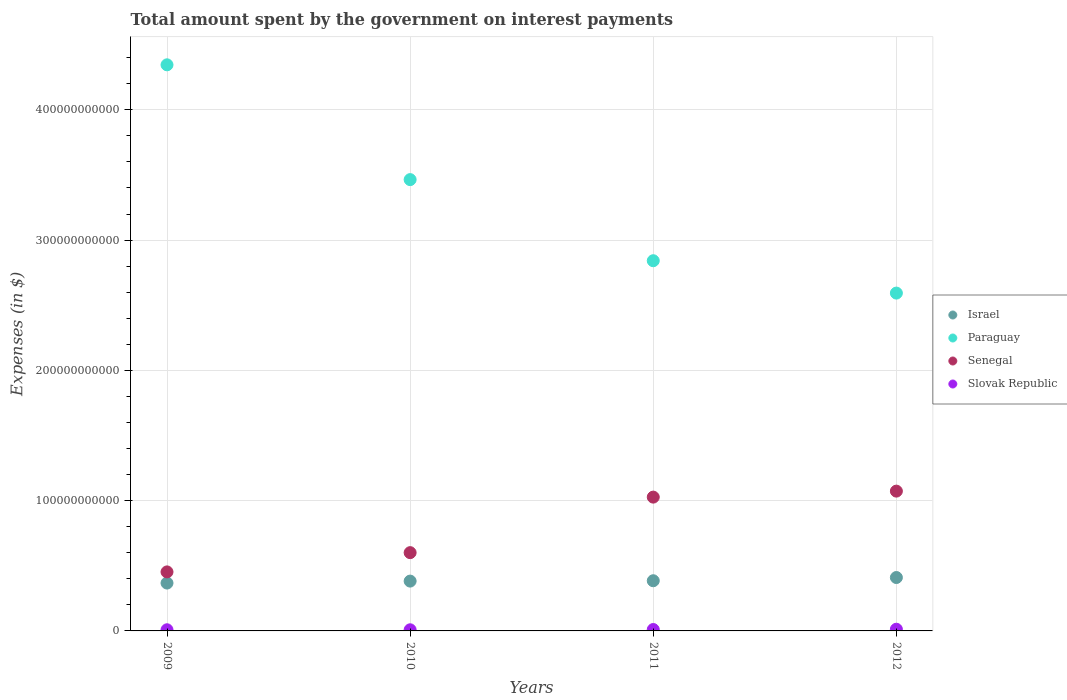How many different coloured dotlines are there?
Your answer should be compact. 4. What is the amount spent on interest payments by the government in Paraguay in 2012?
Make the answer very short. 2.59e+11. Across all years, what is the maximum amount spent on interest payments by the government in Senegal?
Your response must be concise. 1.07e+11. Across all years, what is the minimum amount spent on interest payments by the government in Slovak Republic?
Offer a very short reply. 8.71e+08. In which year was the amount spent on interest payments by the government in Paraguay maximum?
Provide a succinct answer. 2009. What is the total amount spent on interest payments by the government in Paraguay in the graph?
Provide a succinct answer. 1.32e+12. What is the difference between the amount spent on interest payments by the government in Paraguay in 2009 and that in 2011?
Provide a short and direct response. 1.50e+11. What is the difference between the amount spent on interest payments by the government in Israel in 2012 and the amount spent on interest payments by the government in Slovak Republic in 2009?
Offer a terse response. 4.01e+1. What is the average amount spent on interest payments by the government in Paraguay per year?
Make the answer very short. 3.31e+11. In the year 2012, what is the difference between the amount spent on interest payments by the government in Israel and amount spent on interest payments by the government in Senegal?
Your answer should be very brief. -6.63e+1. In how many years, is the amount spent on interest payments by the government in Israel greater than 240000000000 $?
Give a very brief answer. 0. What is the ratio of the amount spent on interest payments by the government in Slovak Republic in 2011 to that in 2012?
Your response must be concise. 0.83. Is the amount spent on interest payments by the government in Paraguay in 2010 less than that in 2012?
Provide a short and direct response. No. What is the difference between the highest and the second highest amount spent on interest payments by the government in Israel?
Make the answer very short. 2.47e+09. What is the difference between the highest and the lowest amount spent on interest payments by the government in Senegal?
Provide a succinct answer. 6.20e+1. In how many years, is the amount spent on interest payments by the government in Slovak Republic greater than the average amount spent on interest payments by the government in Slovak Republic taken over all years?
Give a very brief answer. 2. Is the sum of the amount spent on interest payments by the government in Paraguay in 2009 and 2012 greater than the maximum amount spent on interest payments by the government in Senegal across all years?
Your response must be concise. Yes. Is the amount spent on interest payments by the government in Senegal strictly greater than the amount spent on interest payments by the government in Slovak Republic over the years?
Offer a terse response. Yes. Is the amount spent on interest payments by the government in Israel strictly less than the amount spent on interest payments by the government in Senegal over the years?
Provide a succinct answer. Yes. How many dotlines are there?
Offer a terse response. 4. What is the difference between two consecutive major ticks on the Y-axis?
Offer a terse response. 1.00e+11. How many legend labels are there?
Keep it short and to the point. 4. What is the title of the graph?
Your response must be concise. Total amount spent by the government on interest payments. What is the label or title of the Y-axis?
Provide a succinct answer. Expenses (in $). What is the Expenses (in $) in Israel in 2009?
Offer a very short reply. 3.67e+1. What is the Expenses (in $) of Paraguay in 2009?
Provide a succinct answer. 4.35e+11. What is the Expenses (in $) of Senegal in 2009?
Offer a very short reply. 4.53e+1. What is the Expenses (in $) in Slovak Republic in 2009?
Ensure brevity in your answer.  8.80e+08. What is the Expenses (in $) in Israel in 2010?
Provide a short and direct response. 3.82e+1. What is the Expenses (in $) of Paraguay in 2010?
Keep it short and to the point. 3.46e+11. What is the Expenses (in $) of Senegal in 2010?
Your response must be concise. 6.01e+1. What is the Expenses (in $) of Slovak Republic in 2010?
Offer a terse response. 8.71e+08. What is the Expenses (in $) of Israel in 2011?
Make the answer very short. 3.85e+1. What is the Expenses (in $) in Paraguay in 2011?
Provide a short and direct response. 2.84e+11. What is the Expenses (in $) of Senegal in 2011?
Your response must be concise. 1.03e+11. What is the Expenses (in $) in Slovak Republic in 2011?
Make the answer very short. 1.07e+09. What is the Expenses (in $) of Israel in 2012?
Your response must be concise. 4.10e+1. What is the Expenses (in $) of Paraguay in 2012?
Ensure brevity in your answer.  2.59e+11. What is the Expenses (in $) of Senegal in 2012?
Provide a succinct answer. 1.07e+11. What is the Expenses (in $) of Slovak Republic in 2012?
Offer a very short reply. 1.30e+09. Across all years, what is the maximum Expenses (in $) of Israel?
Your answer should be compact. 4.10e+1. Across all years, what is the maximum Expenses (in $) in Paraguay?
Ensure brevity in your answer.  4.35e+11. Across all years, what is the maximum Expenses (in $) of Senegal?
Provide a short and direct response. 1.07e+11. Across all years, what is the maximum Expenses (in $) of Slovak Republic?
Make the answer very short. 1.30e+09. Across all years, what is the minimum Expenses (in $) in Israel?
Give a very brief answer. 3.67e+1. Across all years, what is the minimum Expenses (in $) of Paraguay?
Your answer should be compact. 2.59e+11. Across all years, what is the minimum Expenses (in $) of Senegal?
Give a very brief answer. 4.53e+1. Across all years, what is the minimum Expenses (in $) of Slovak Republic?
Your response must be concise. 8.71e+08. What is the total Expenses (in $) in Israel in the graph?
Give a very brief answer. 1.54e+11. What is the total Expenses (in $) in Paraguay in the graph?
Ensure brevity in your answer.  1.32e+12. What is the total Expenses (in $) of Senegal in the graph?
Offer a terse response. 3.15e+11. What is the total Expenses (in $) in Slovak Republic in the graph?
Make the answer very short. 4.12e+09. What is the difference between the Expenses (in $) in Israel in 2009 and that in 2010?
Offer a terse response. -1.51e+09. What is the difference between the Expenses (in $) in Paraguay in 2009 and that in 2010?
Give a very brief answer. 8.81e+1. What is the difference between the Expenses (in $) of Senegal in 2009 and that in 2010?
Offer a very short reply. -1.48e+1. What is the difference between the Expenses (in $) in Slovak Republic in 2009 and that in 2010?
Your answer should be compact. 9.30e+06. What is the difference between the Expenses (in $) of Israel in 2009 and that in 2011?
Provide a short and direct response. -1.78e+09. What is the difference between the Expenses (in $) in Paraguay in 2009 and that in 2011?
Your answer should be compact. 1.50e+11. What is the difference between the Expenses (in $) of Senegal in 2009 and that in 2011?
Make the answer very short. -5.74e+1. What is the difference between the Expenses (in $) in Slovak Republic in 2009 and that in 2011?
Provide a succinct answer. -1.91e+08. What is the difference between the Expenses (in $) in Israel in 2009 and that in 2012?
Keep it short and to the point. -4.25e+09. What is the difference between the Expenses (in $) in Paraguay in 2009 and that in 2012?
Offer a very short reply. 1.75e+11. What is the difference between the Expenses (in $) of Senegal in 2009 and that in 2012?
Offer a very short reply. -6.20e+1. What is the difference between the Expenses (in $) of Slovak Republic in 2009 and that in 2012?
Make the answer very short. -4.18e+08. What is the difference between the Expenses (in $) in Israel in 2010 and that in 2011?
Your response must be concise. -2.71e+08. What is the difference between the Expenses (in $) of Paraguay in 2010 and that in 2011?
Offer a terse response. 6.23e+1. What is the difference between the Expenses (in $) in Senegal in 2010 and that in 2011?
Your answer should be very brief. -4.26e+1. What is the difference between the Expenses (in $) of Slovak Republic in 2010 and that in 2011?
Ensure brevity in your answer.  -2.00e+08. What is the difference between the Expenses (in $) of Israel in 2010 and that in 2012?
Your response must be concise. -2.74e+09. What is the difference between the Expenses (in $) in Paraguay in 2010 and that in 2012?
Provide a succinct answer. 8.71e+1. What is the difference between the Expenses (in $) of Senegal in 2010 and that in 2012?
Ensure brevity in your answer.  -4.72e+1. What is the difference between the Expenses (in $) in Slovak Republic in 2010 and that in 2012?
Ensure brevity in your answer.  -4.27e+08. What is the difference between the Expenses (in $) in Israel in 2011 and that in 2012?
Provide a succinct answer. -2.47e+09. What is the difference between the Expenses (in $) of Paraguay in 2011 and that in 2012?
Your response must be concise. 2.48e+1. What is the difference between the Expenses (in $) in Senegal in 2011 and that in 2012?
Give a very brief answer. -4.60e+09. What is the difference between the Expenses (in $) in Slovak Republic in 2011 and that in 2012?
Make the answer very short. -2.27e+08. What is the difference between the Expenses (in $) in Israel in 2009 and the Expenses (in $) in Paraguay in 2010?
Your answer should be compact. -3.10e+11. What is the difference between the Expenses (in $) of Israel in 2009 and the Expenses (in $) of Senegal in 2010?
Your response must be concise. -2.33e+1. What is the difference between the Expenses (in $) in Israel in 2009 and the Expenses (in $) in Slovak Republic in 2010?
Make the answer very short. 3.59e+1. What is the difference between the Expenses (in $) of Paraguay in 2009 and the Expenses (in $) of Senegal in 2010?
Offer a very short reply. 3.74e+11. What is the difference between the Expenses (in $) in Paraguay in 2009 and the Expenses (in $) in Slovak Republic in 2010?
Offer a terse response. 4.34e+11. What is the difference between the Expenses (in $) in Senegal in 2009 and the Expenses (in $) in Slovak Republic in 2010?
Keep it short and to the point. 4.44e+1. What is the difference between the Expenses (in $) of Israel in 2009 and the Expenses (in $) of Paraguay in 2011?
Your response must be concise. -2.47e+11. What is the difference between the Expenses (in $) in Israel in 2009 and the Expenses (in $) in Senegal in 2011?
Offer a very short reply. -6.60e+1. What is the difference between the Expenses (in $) of Israel in 2009 and the Expenses (in $) of Slovak Republic in 2011?
Give a very brief answer. 3.57e+1. What is the difference between the Expenses (in $) of Paraguay in 2009 and the Expenses (in $) of Senegal in 2011?
Provide a succinct answer. 3.32e+11. What is the difference between the Expenses (in $) of Paraguay in 2009 and the Expenses (in $) of Slovak Republic in 2011?
Give a very brief answer. 4.33e+11. What is the difference between the Expenses (in $) of Senegal in 2009 and the Expenses (in $) of Slovak Republic in 2011?
Make the answer very short. 4.42e+1. What is the difference between the Expenses (in $) in Israel in 2009 and the Expenses (in $) in Paraguay in 2012?
Give a very brief answer. -2.23e+11. What is the difference between the Expenses (in $) in Israel in 2009 and the Expenses (in $) in Senegal in 2012?
Make the answer very short. -7.06e+1. What is the difference between the Expenses (in $) in Israel in 2009 and the Expenses (in $) in Slovak Republic in 2012?
Provide a short and direct response. 3.54e+1. What is the difference between the Expenses (in $) in Paraguay in 2009 and the Expenses (in $) in Senegal in 2012?
Offer a terse response. 3.27e+11. What is the difference between the Expenses (in $) of Paraguay in 2009 and the Expenses (in $) of Slovak Republic in 2012?
Ensure brevity in your answer.  4.33e+11. What is the difference between the Expenses (in $) in Senegal in 2009 and the Expenses (in $) in Slovak Republic in 2012?
Your response must be concise. 4.40e+1. What is the difference between the Expenses (in $) of Israel in 2010 and the Expenses (in $) of Paraguay in 2011?
Keep it short and to the point. -2.46e+11. What is the difference between the Expenses (in $) in Israel in 2010 and the Expenses (in $) in Senegal in 2011?
Make the answer very short. -6.45e+1. What is the difference between the Expenses (in $) of Israel in 2010 and the Expenses (in $) of Slovak Republic in 2011?
Your response must be concise. 3.72e+1. What is the difference between the Expenses (in $) of Paraguay in 2010 and the Expenses (in $) of Senegal in 2011?
Give a very brief answer. 2.44e+11. What is the difference between the Expenses (in $) in Paraguay in 2010 and the Expenses (in $) in Slovak Republic in 2011?
Provide a succinct answer. 3.45e+11. What is the difference between the Expenses (in $) in Senegal in 2010 and the Expenses (in $) in Slovak Republic in 2011?
Offer a very short reply. 5.90e+1. What is the difference between the Expenses (in $) in Israel in 2010 and the Expenses (in $) in Paraguay in 2012?
Your answer should be very brief. -2.21e+11. What is the difference between the Expenses (in $) in Israel in 2010 and the Expenses (in $) in Senegal in 2012?
Provide a succinct answer. -6.91e+1. What is the difference between the Expenses (in $) of Israel in 2010 and the Expenses (in $) of Slovak Republic in 2012?
Offer a terse response. 3.69e+1. What is the difference between the Expenses (in $) in Paraguay in 2010 and the Expenses (in $) in Senegal in 2012?
Offer a terse response. 2.39e+11. What is the difference between the Expenses (in $) in Paraguay in 2010 and the Expenses (in $) in Slovak Republic in 2012?
Your answer should be very brief. 3.45e+11. What is the difference between the Expenses (in $) of Senegal in 2010 and the Expenses (in $) of Slovak Republic in 2012?
Make the answer very short. 5.88e+1. What is the difference between the Expenses (in $) in Israel in 2011 and the Expenses (in $) in Paraguay in 2012?
Offer a terse response. -2.21e+11. What is the difference between the Expenses (in $) in Israel in 2011 and the Expenses (in $) in Senegal in 2012?
Offer a very short reply. -6.88e+1. What is the difference between the Expenses (in $) in Israel in 2011 and the Expenses (in $) in Slovak Republic in 2012?
Your answer should be compact. 3.72e+1. What is the difference between the Expenses (in $) in Paraguay in 2011 and the Expenses (in $) in Senegal in 2012?
Offer a very short reply. 1.77e+11. What is the difference between the Expenses (in $) in Paraguay in 2011 and the Expenses (in $) in Slovak Republic in 2012?
Provide a short and direct response. 2.83e+11. What is the difference between the Expenses (in $) of Senegal in 2011 and the Expenses (in $) of Slovak Republic in 2012?
Ensure brevity in your answer.  1.01e+11. What is the average Expenses (in $) of Israel per year?
Your answer should be compact. 3.86e+1. What is the average Expenses (in $) of Paraguay per year?
Your response must be concise. 3.31e+11. What is the average Expenses (in $) in Senegal per year?
Offer a very short reply. 7.88e+1. What is the average Expenses (in $) of Slovak Republic per year?
Your response must be concise. 1.03e+09. In the year 2009, what is the difference between the Expenses (in $) in Israel and Expenses (in $) in Paraguay?
Keep it short and to the point. -3.98e+11. In the year 2009, what is the difference between the Expenses (in $) in Israel and Expenses (in $) in Senegal?
Your answer should be compact. -8.56e+09. In the year 2009, what is the difference between the Expenses (in $) of Israel and Expenses (in $) of Slovak Republic?
Offer a terse response. 3.59e+1. In the year 2009, what is the difference between the Expenses (in $) in Paraguay and Expenses (in $) in Senegal?
Make the answer very short. 3.89e+11. In the year 2009, what is the difference between the Expenses (in $) in Paraguay and Expenses (in $) in Slovak Republic?
Give a very brief answer. 4.34e+11. In the year 2009, what is the difference between the Expenses (in $) of Senegal and Expenses (in $) of Slovak Republic?
Provide a succinct answer. 4.44e+1. In the year 2010, what is the difference between the Expenses (in $) of Israel and Expenses (in $) of Paraguay?
Ensure brevity in your answer.  -3.08e+11. In the year 2010, what is the difference between the Expenses (in $) in Israel and Expenses (in $) in Senegal?
Your response must be concise. -2.18e+1. In the year 2010, what is the difference between the Expenses (in $) in Israel and Expenses (in $) in Slovak Republic?
Make the answer very short. 3.74e+1. In the year 2010, what is the difference between the Expenses (in $) of Paraguay and Expenses (in $) of Senegal?
Give a very brief answer. 2.86e+11. In the year 2010, what is the difference between the Expenses (in $) of Paraguay and Expenses (in $) of Slovak Republic?
Provide a succinct answer. 3.46e+11. In the year 2010, what is the difference between the Expenses (in $) of Senegal and Expenses (in $) of Slovak Republic?
Your answer should be compact. 5.92e+1. In the year 2011, what is the difference between the Expenses (in $) of Israel and Expenses (in $) of Paraguay?
Your response must be concise. -2.46e+11. In the year 2011, what is the difference between the Expenses (in $) of Israel and Expenses (in $) of Senegal?
Your response must be concise. -6.42e+1. In the year 2011, what is the difference between the Expenses (in $) of Israel and Expenses (in $) of Slovak Republic?
Offer a very short reply. 3.74e+1. In the year 2011, what is the difference between the Expenses (in $) of Paraguay and Expenses (in $) of Senegal?
Your response must be concise. 1.81e+11. In the year 2011, what is the difference between the Expenses (in $) in Paraguay and Expenses (in $) in Slovak Republic?
Give a very brief answer. 2.83e+11. In the year 2011, what is the difference between the Expenses (in $) in Senegal and Expenses (in $) in Slovak Republic?
Provide a short and direct response. 1.02e+11. In the year 2012, what is the difference between the Expenses (in $) of Israel and Expenses (in $) of Paraguay?
Offer a very short reply. -2.18e+11. In the year 2012, what is the difference between the Expenses (in $) of Israel and Expenses (in $) of Senegal?
Your answer should be compact. -6.63e+1. In the year 2012, what is the difference between the Expenses (in $) in Israel and Expenses (in $) in Slovak Republic?
Offer a terse response. 3.97e+1. In the year 2012, what is the difference between the Expenses (in $) of Paraguay and Expenses (in $) of Senegal?
Your answer should be very brief. 1.52e+11. In the year 2012, what is the difference between the Expenses (in $) of Paraguay and Expenses (in $) of Slovak Republic?
Ensure brevity in your answer.  2.58e+11. In the year 2012, what is the difference between the Expenses (in $) in Senegal and Expenses (in $) in Slovak Republic?
Ensure brevity in your answer.  1.06e+11. What is the ratio of the Expenses (in $) in Israel in 2009 to that in 2010?
Your answer should be very brief. 0.96. What is the ratio of the Expenses (in $) of Paraguay in 2009 to that in 2010?
Provide a short and direct response. 1.25. What is the ratio of the Expenses (in $) of Senegal in 2009 to that in 2010?
Provide a short and direct response. 0.75. What is the ratio of the Expenses (in $) in Slovak Republic in 2009 to that in 2010?
Offer a terse response. 1.01. What is the ratio of the Expenses (in $) of Israel in 2009 to that in 2011?
Your response must be concise. 0.95. What is the ratio of the Expenses (in $) of Paraguay in 2009 to that in 2011?
Provide a succinct answer. 1.53. What is the ratio of the Expenses (in $) in Senegal in 2009 to that in 2011?
Offer a very short reply. 0.44. What is the ratio of the Expenses (in $) in Slovak Republic in 2009 to that in 2011?
Provide a succinct answer. 0.82. What is the ratio of the Expenses (in $) in Israel in 2009 to that in 2012?
Your response must be concise. 0.9. What is the ratio of the Expenses (in $) in Paraguay in 2009 to that in 2012?
Your response must be concise. 1.68. What is the ratio of the Expenses (in $) of Senegal in 2009 to that in 2012?
Give a very brief answer. 0.42. What is the ratio of the Expenses (in $) of Slovak Republic in 2009 to that in 2012?
Your answer should be very brief. 0.68. What is the ratio of the Expenses (in $) in Israel in 2010 to that in 2011?
Your response must be concise. 0.99. What is the ratio of the Expenses (in $) in Paraguay in 2010 to that in 2011?
Provide a short and direct response. 1.22. What is the ratio of the Expenses (in $) of Senegal in 2010 to that in 2011?
Provide a succinct answer. 0.58. What is the ratio of the Expenses (in $) of Slovak Republic in 2010 to that in 2011?
Provide a succinct answer. 0.81. What is the ratio of the Expenses (in $) of Israel in 2010 to that in 2012?
Keep it short and to the point. 0.93. What is the ratio of the Expenses (in $) of Paraguay in 2010 to that in 2012?
Offer a terse response. 1.34. What is the ratio of the Expenses (in $) in Senegal in 2010 to that in 2012?
Give a very brief answer. 0.56. What is the ratio of the Expenses (in $) in Slovak Republic in 2010 to that in 2012?
Your answer should be compact. 0.67. What is the ratio of the Expenses (in $) in Israel in 2011 to that in 2012?
Offer a very short reply. 0.94. What is the ratio of the Expenses (in $) of Paraguay in 2011 to that in 2012?
Provide a short and direct response. 1.1. What is the ratio of the Expenses (in $) in Senegal in 2011 to that in 2012?
Your response must be concise. 0.96. What is the ratio of the Expenses (in $) of Slovak Republic in 2011 to that in 2012?
Your answer should be very brief. 0.83. What is the difference between the highest and the second highest Expenses (in $) of Israel?
Offer a terse response. 2.47e+09. What is the difference between the highest and the second highest Expenses (in $) in Paraguay?
Keep it short and to the point. 8.81e+1. What is the difference between the highest and the second highest Expenses (in $) in Senegal?
Make the answer very short. 4.60e+09. What is the difference between the highest and the second highest Expenses (in $) in Slovak Republic?
Your answer should be compact. 2.27e+08. What is the difference between the highest and the lowest Expenses (in $) in Israel?
Your answer should be very brief. 4.25e+09. What is the difference between the highest and the lowest Expenses (in $) in Paraguay?
Ensure brevity in your answer.  1.75e+11. What is the difference between the highest and the lowest Expenses (in $) in Senegal?
Keep it short and to the point. 6.20e+1. What is the difference between the highest and the lowest Expenses (in $) in Slovak Republic?
Offer a terse response. 4.27e+08. 